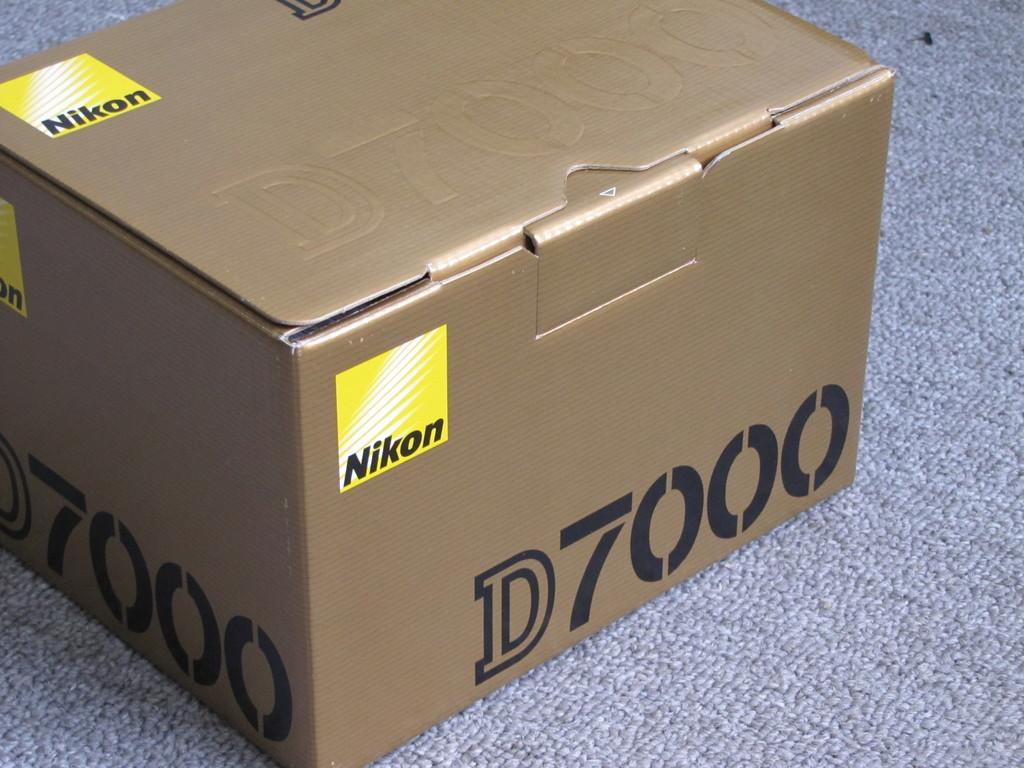<image>
Describe the image concisely. A cardboard box from Nikon is shown sitting on a carpet. 